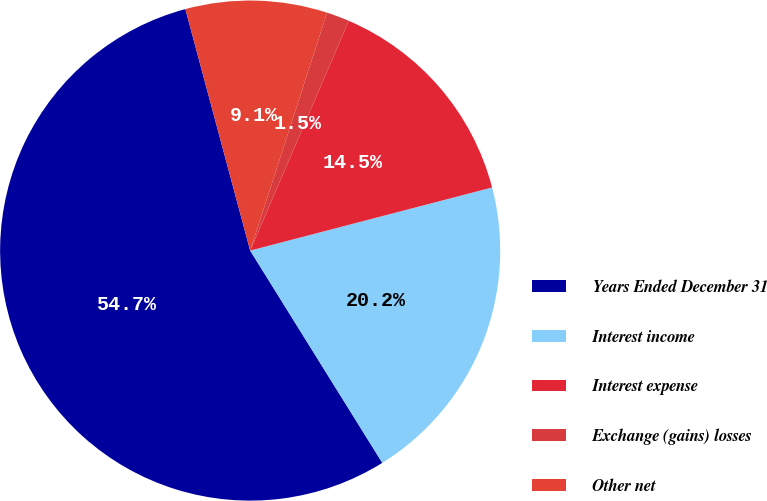<chart> <loc_0><loc_0><loc_500><loc_500><pie_chart><fcel>Years Ended December 31<fcel>Interest income<fcel>Interest expense<fcel>Exchange (gains) losses<fcel>Other net<nl><fcel>54.69%<fcel>20.2%<fcel>14.48%<fcel>1.48%<fcel>9.15%<nl></chart> 